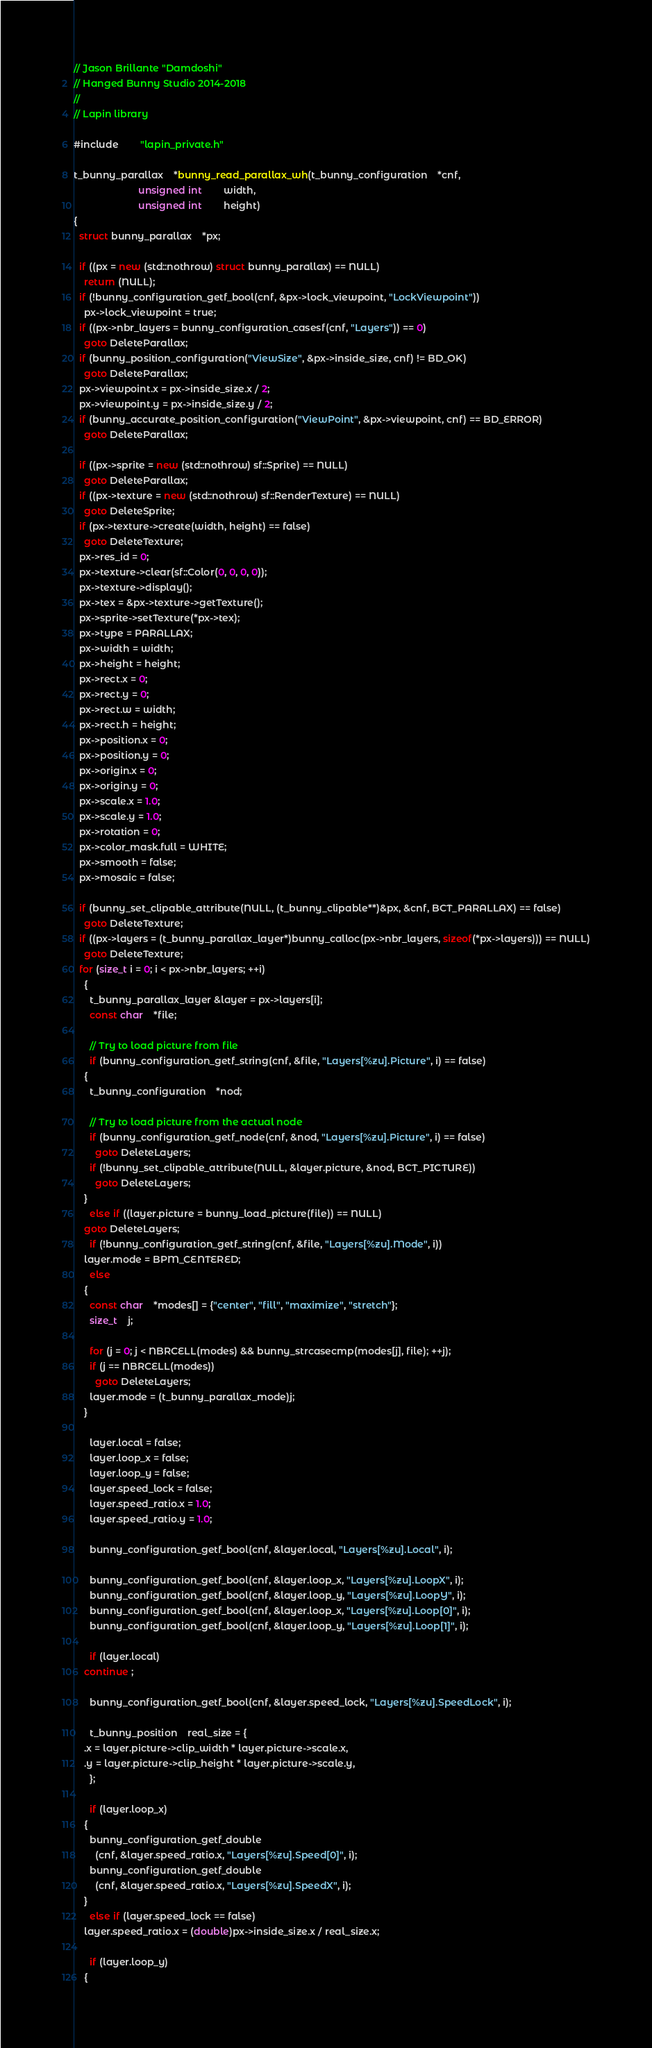<code> <loc_0><loc_0><loc_500><loc_500><_C++_>// Jason Brillante "Damdoshi"
// Hanged Bunny Studio 2014-2018
//
// Lapin library

#include		"lapin_private.h"

t_bunny_parallax	*bunny_read_parallax_wh(t_bunny_configuration	*cnf,
						unsigned int		width,
						unsigned int		height)
{
  struct bunny_parallax	*px;

  if ((px = new (std::nothrow) struct bunny_parallax) == NULL)
    return (NULL);
  if (!bunny_configuration_getf_bool(cnf, &px->lock_viewpoint, "LockViewpoint"))
    px->lock_viewpoint = true;
  if ((px->nbr_layers = bunny_configuration_casesf(cnf, "Layers")) == 0)
    goto DeleteParallax;
  if (bunny_position_configuration("ViewSize", &px->inside_size, cnf) != BD_OK)
    goto DeleteParallax;
  px->viewpoint.x = px->inside_size.x / 2;
  px->viewpoint.y = px->inside_size.y / 2;
  if (bunny_accurate_position_configuration("ViewPoint", &px->viewpoint, cnf) == BD_ERROR)
    goto DeleteParallax;

  if ((px->sprite = new (std::nothrow) sf::Sprite) == NULL)
    goto DeleteParallax;
  if ((px->texture = new (std::nothrow) sf::RenderTexture) == NULL)
    goto DeleteSprite;
  if (px->texture->create(width, height) == false)
    goto DeleteTexture;
  px->res_id = 0;
  px->texture->clear(sf::Color(0, 0, 0, 0));
  px->texture->display();
  px->tex = &px->texture->getTexture();
  px->sprite->setTexture(*px->tex);
  px->type = PARALLAX;
  px->width = width;
  px->height = height;
  px->rect.x = 0;
  px->rect.y = 0;
  px->rect.w = width;
  px->rect.h = height;
  px->position.x = 0;
  px->position.y = 0;
  px->origin.x = 0;
  px->origin.y = 0;
  px->scale.x = 1.0;
  px->scale.y = 1.0;
  px->rotation = 0;
  px->color_mask.full = WHITE;
  px->smooth = false;
  px->mosaic = false;

  if (bunny_set_clipable_attribute(NULL, (t_bunny_clipable**)&px, &cnf, BCT_PARALLAX) == false)
    goto DeleteTexture;
  if ((px->layers = (t_bunny_parallax_layer*)bunny_calloc(px->nbr_layers, sizeof(*px->layers))) == NULL)
    goto DeleteTexture;
  for (size_t i = 0; i < px->nbr_layers; ++i)
    {
      t_bunny_parallax_layer &layer = px->layers[i];
      const char	*file;

      // Try to load picture from file
      if (bunny_configuration_getf_string(cnf, &file, "Layers[%zu].Picture", i) == false)
	{
	  t_bunny_configuration	*nod;

	  // Try to load picture from the actual node
	  if (bunny_configuration_getf_node(cnf, &nod, "Layers[%zu].Picture", i) == false)
	    goto DeleteLayers;
	  if (!bunny_set_clipable_attribute(NULL, &layer.picture, &nod, BCT_PICTURE))
	    goto DeleteLayers;
	}
      else if ((layer.picture = bunny_load_picture(file)) == NULL)
	goto DeleteLayers;
      if (!bunny_configuration_getf_string(cnf, &file, "Layers[%zu].Mode", i))
	layer.mode = BPM_CENTERED;
      else
	{
	  const char	*modes[] = {"center", "fill", "maximize", "stretch"};
	  size_t	j;

	  for (j = 0; j < NBRCELL(modes) && bunny_strcasecmp(modes[j], file); ++j);
	  if (j == NBRCELL(modes))
	    goto DeleteLayers;
	  layer.mode = (t_bunny_parallax_mode)j;
	}

      layer.local = false;
      layer.loop_x = false;
      layer.loop_y = false;
      layer.speed_lock = false;
      layer.speed_ratio.x = 1.0;
      layer.speed_ratio.y = 1.0;

      bunny_configuration_getf_bool(cnf, &layer.local, "Layers[%zu].Local", i);

      bunny_configuration_getf_bool(cnf, &layer.loop_x, "Layers[%zu].LoopX", i);
      bunny_configuration_getf_bool(cnf, &layer.loop_y, "Layers[%zu].LoopY", i);
      bunny_configuration_getf_bool(cnf, &layer.loop_x, "Layers[%zu].Loop[0]", i);
      bunny_configuration_getf_bool(cnf, &layer.loop_y, "Layers[%zu].Loop[1]", i);

      if (layer.local)
	continue ;

      bunny_configuration_getf_bool(cnf, &layer.speed_lock, "Layers[%zu].SpeedLock", i);

      t_bunny_position	real_size = {
	.x = layer.picture->clip_width * layer.picture->scale.x,
	.y = layer.picture->clip_height * layer.picture->scale.y,
      };

      if (layer.loop_x)
	{
	  bunny_configuration_getf_double
	    (cnf, &layer.speed_ratio.x, "Layers[%zu].Speed[0]", i);
	  bunny_configuration_getf_double
	    (cnf, &layer.speed_ratio.x, "Layers[%zu].SpeedX", i);
	}
      else if (layer.speed_lock == false)
	layer.speed_ratio.x = (double)px->inside_size.x / real_size.x;

      if (layer.loop_y)
	{</code> 